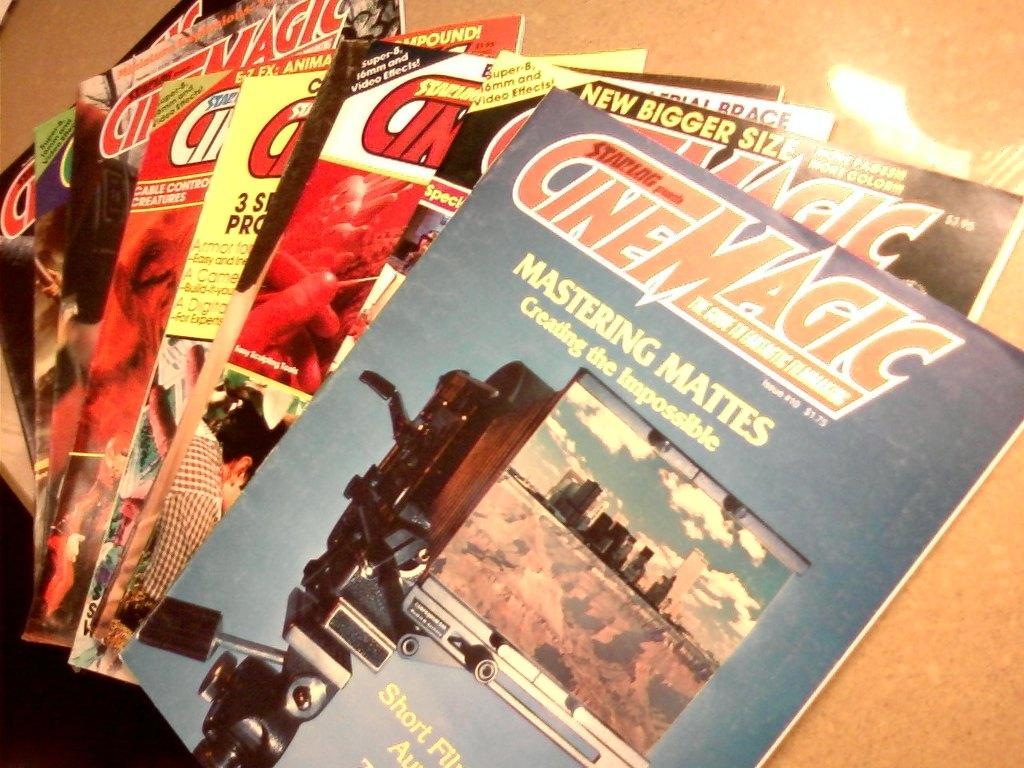<image>
Give a short and clear explanation of the subsequent image. A stack of nine different Cinemagic magazines about photography 